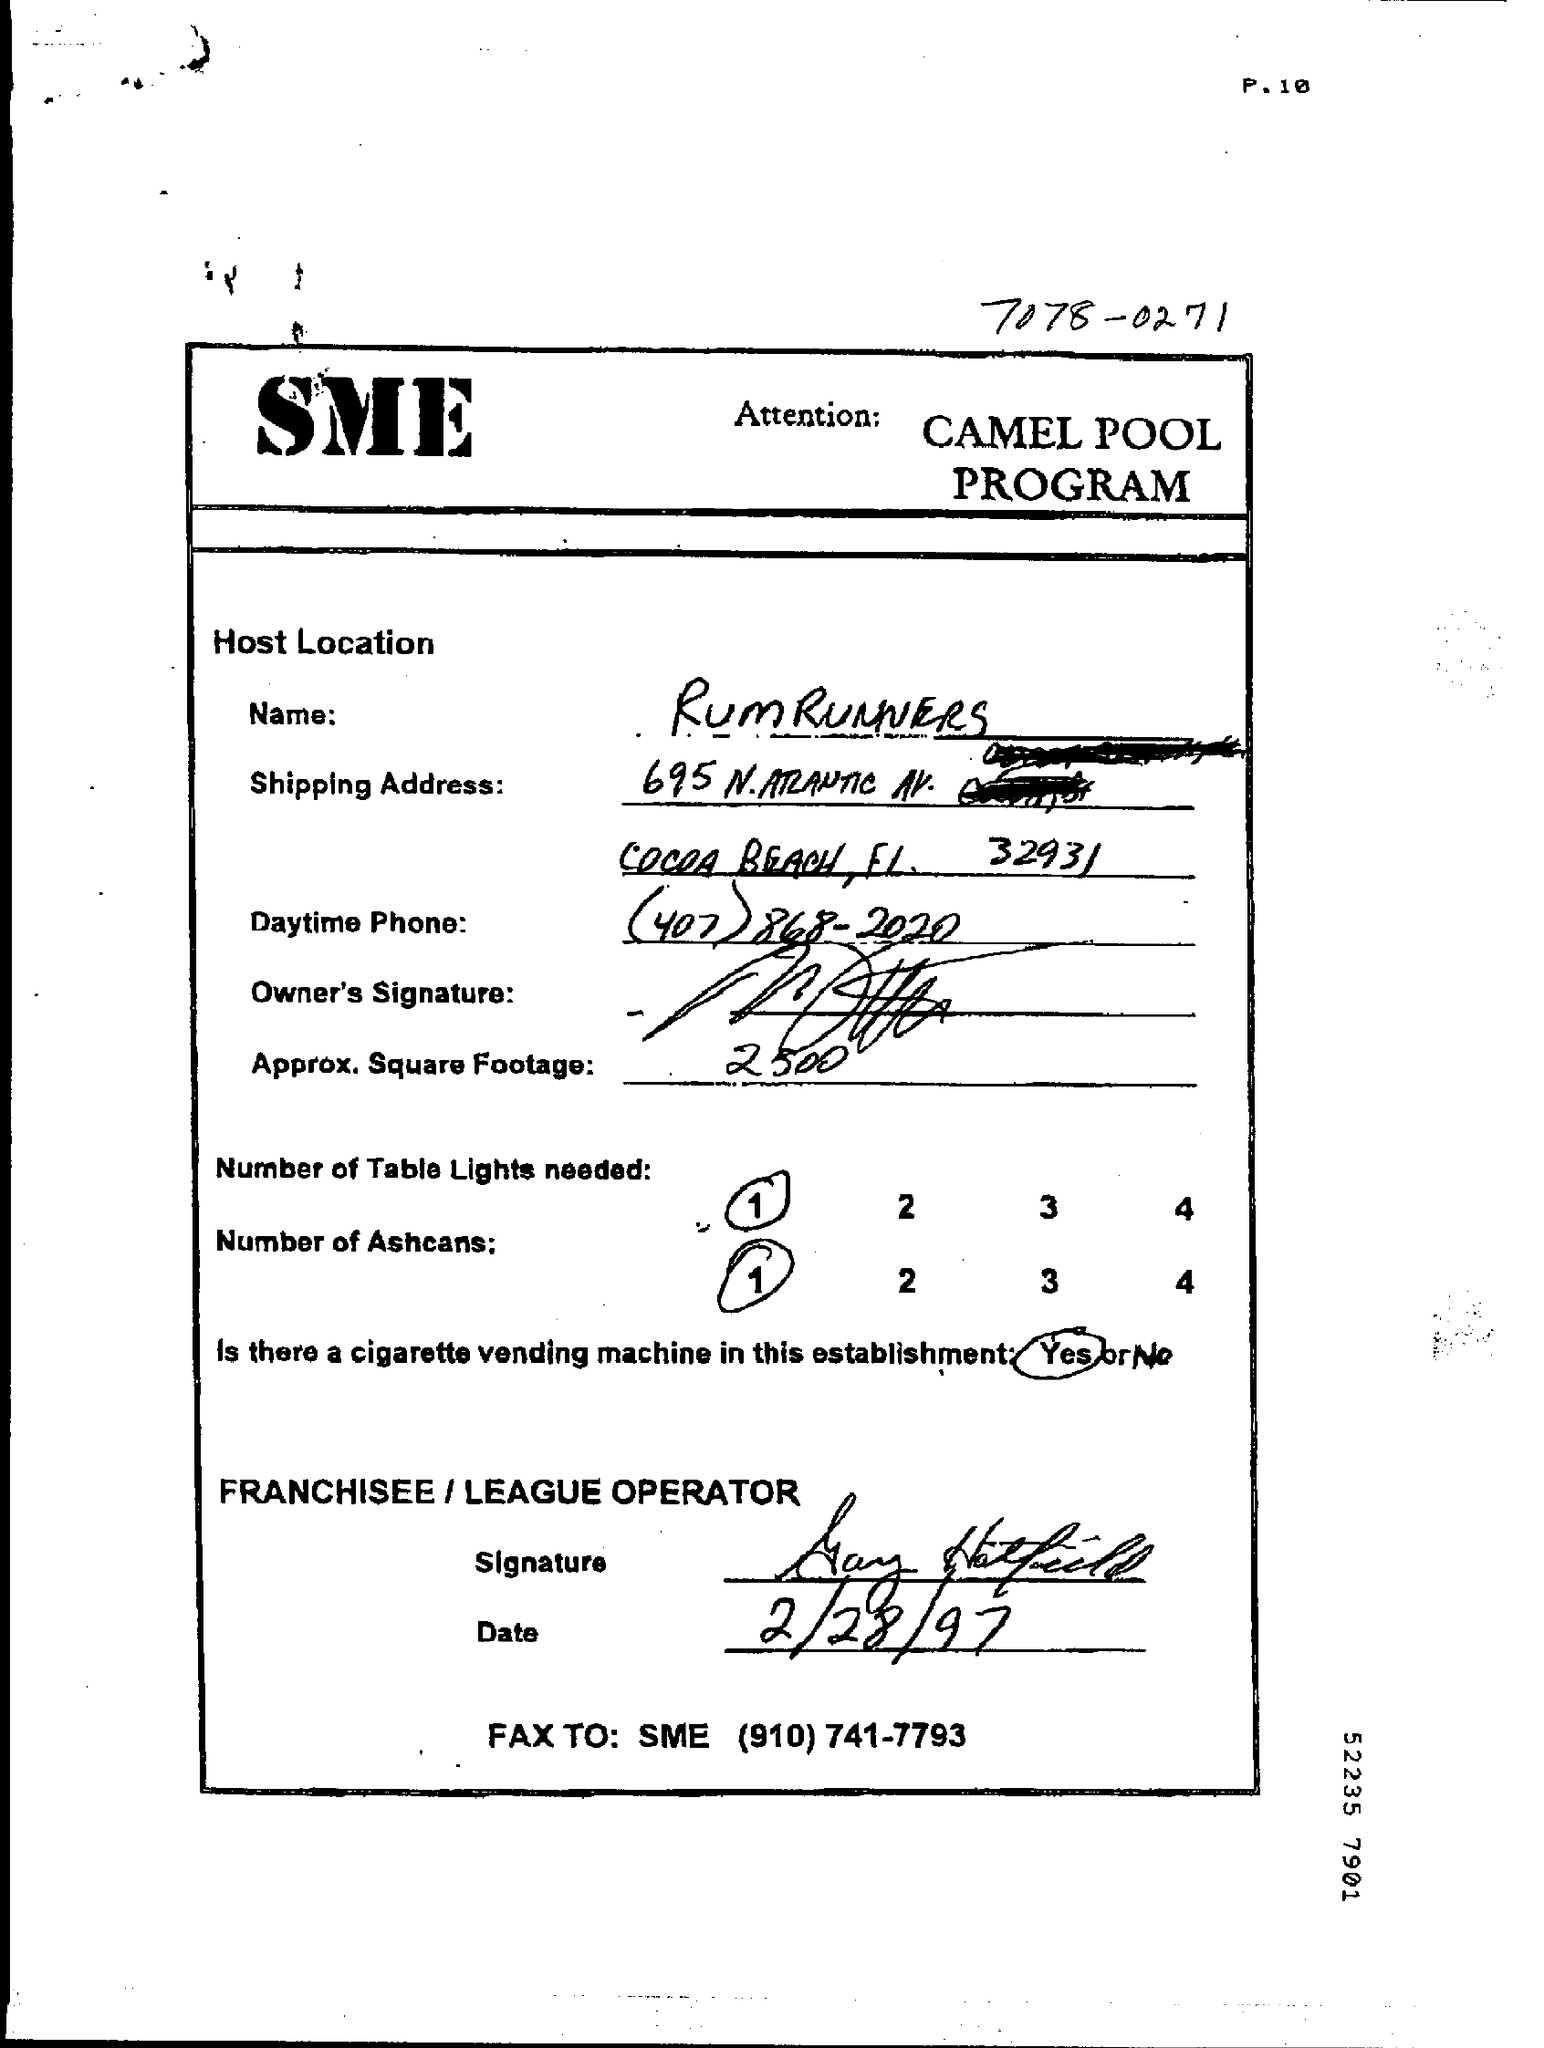Indicate a few pertinent items in this graphic. The name that is mentioned is "RUM RUNNERS". The date of the document is February 28, 1997. 